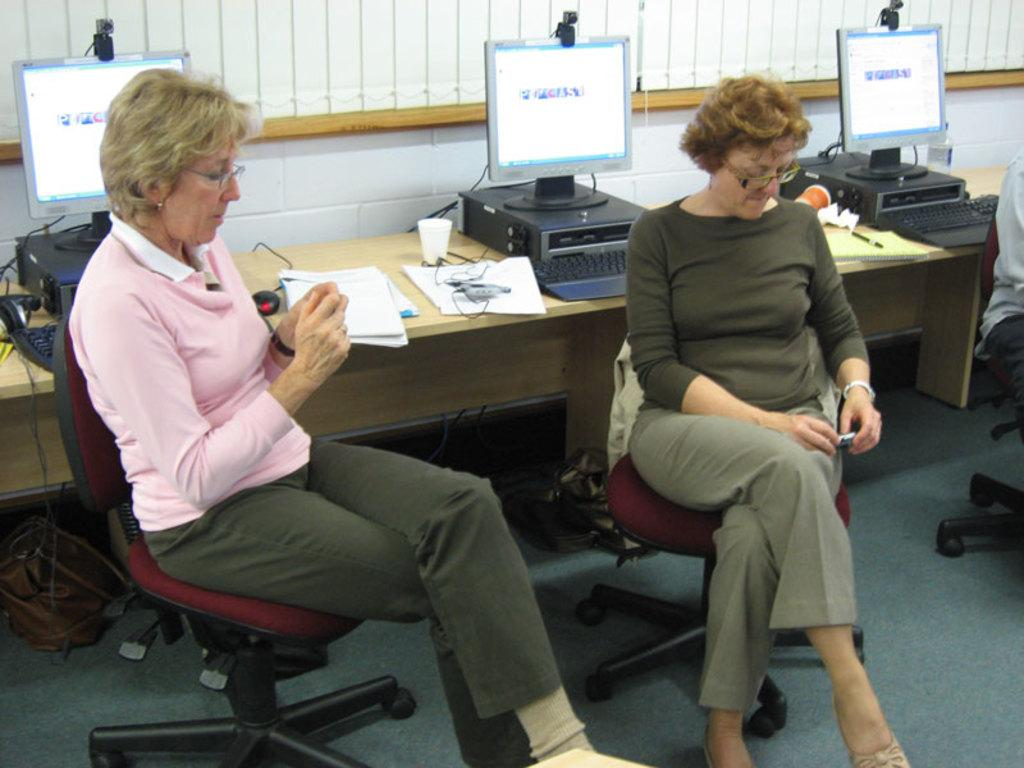How many people are in the image? There are two men in the image. What are the men doing in the image? The men are seated on chairs. What objects are the men holding in their hands? Both men are holding a mobile in their hands. What can be seen on the table in the image? There are three computers, papers, and cups on the table. What type of brush is the man using to paint the suit in the image? There is no brush or suit present in the image; the men are holding mobiles and there are computers, papers, and cups on the table. 